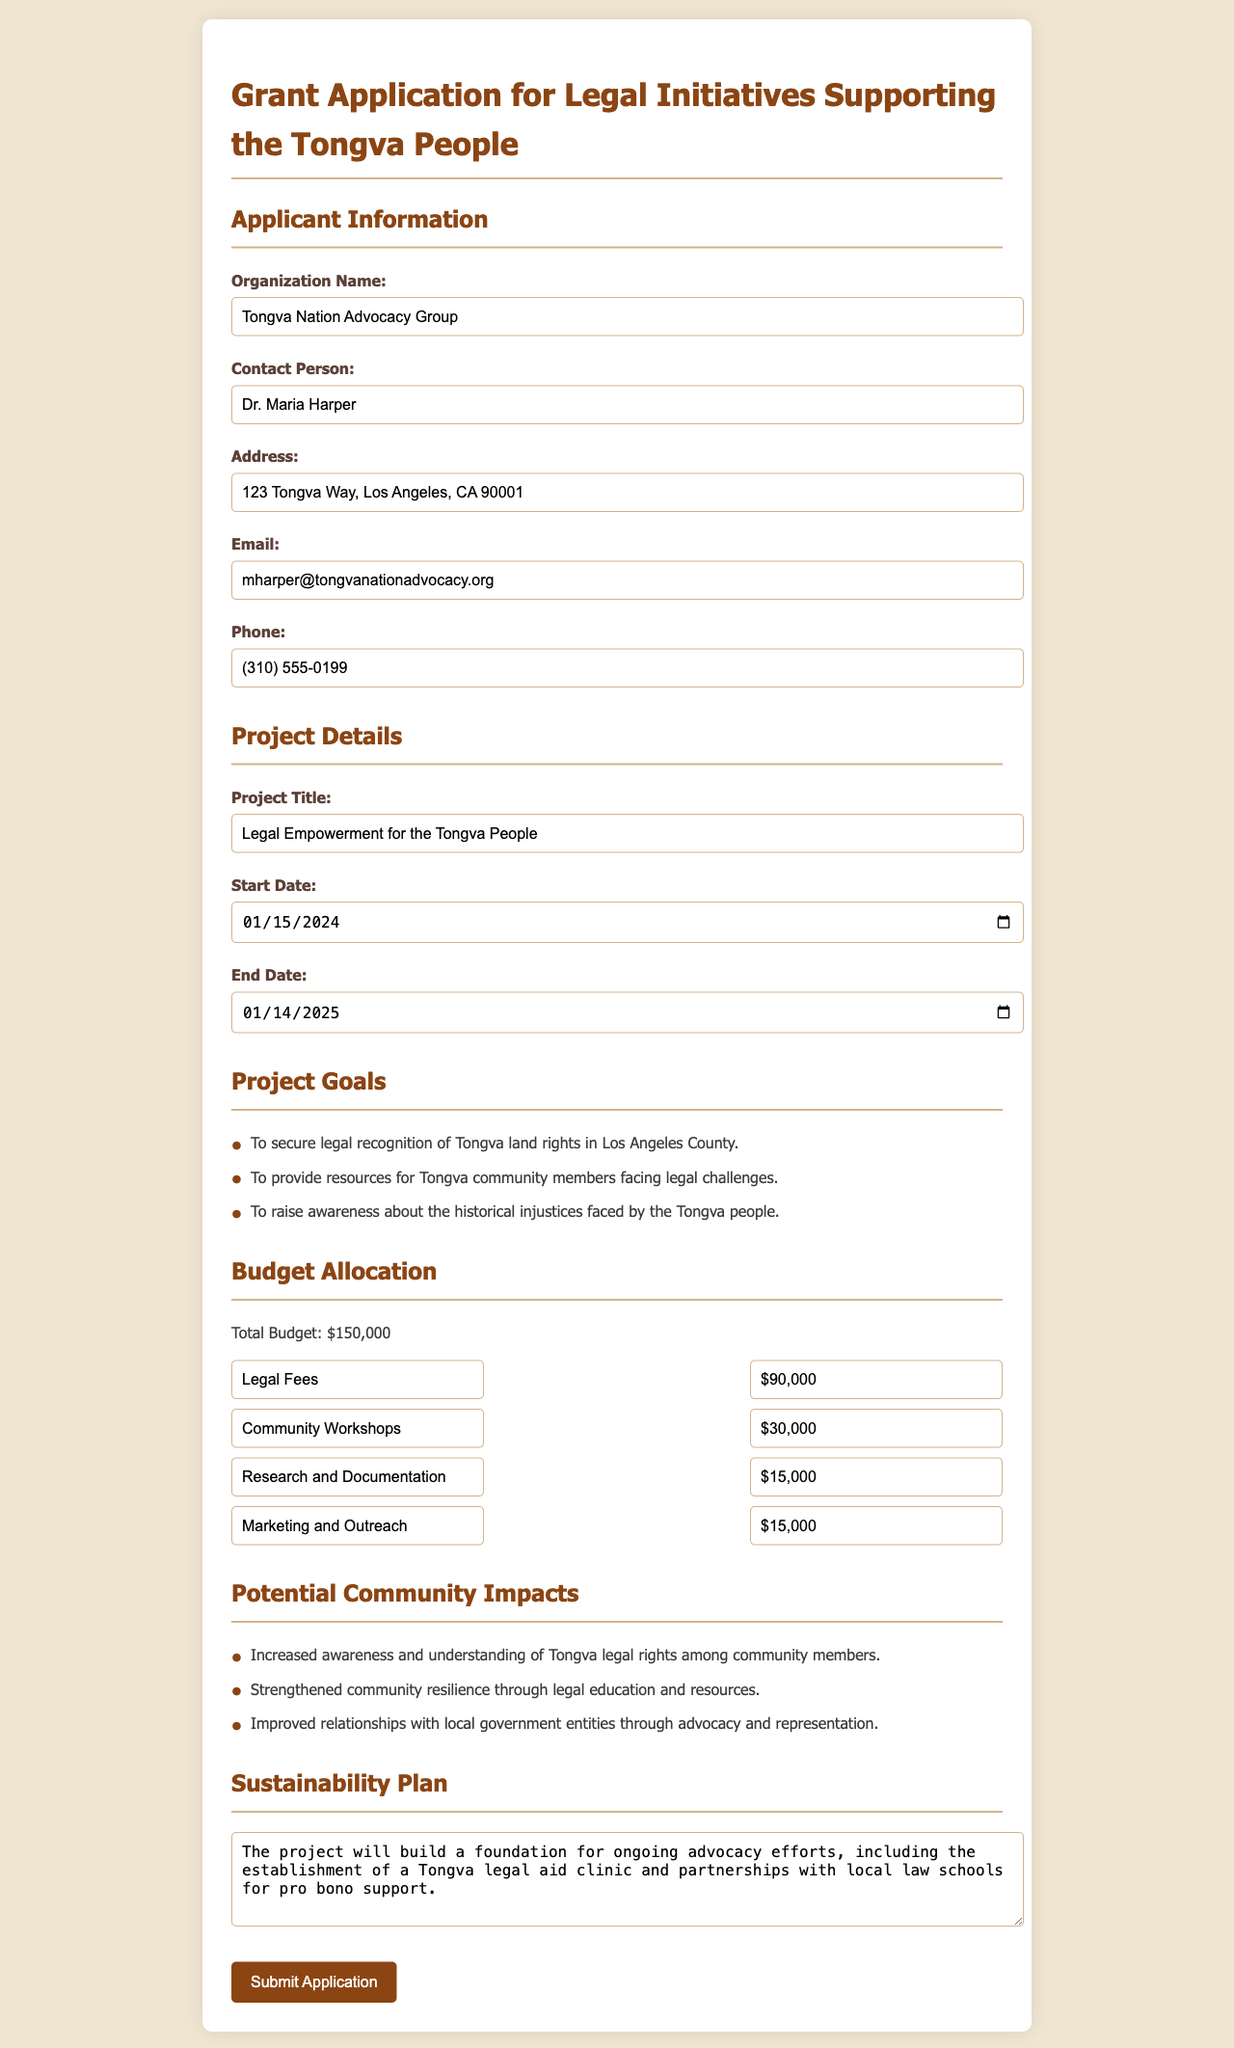What is the organization name? The organization name is mentioned in the applicant information section of the document.
Answer: Tongva Nation Advocacy Group Who is the contact person for the application? The contact person's name is provided in the applicant information section.
Answer: Dr. Maria Harper What is the project title? The project title is clearly stated in the project details section of the document.
Answer: Legal Empowerment for the Tongva People What is the total budget for the project? The total budget can be found in the budget allocation section.
Answer: $150,000 How much funding is allocated for legal fees? The amount for legal fees is specified in the budget allocation section.
Answer: $90,000 What are the start and end dates of the project? Both dates can be found in the project details section as they are provided clearly.
Answer: January 15, 2024 - January 14, 2025 Name one goal of the project. One of the goals is listed in the project goals section.
Answer: To secure legal recognition of Tongva land rights in Los Angeles County What is one potential community impact of the project? The impacts are listed in the potential community impacts section, and one can be chosen from those listed.
Answer: Increased awareness and understanding of Tongva legal rights among community members What is the sustainability plan focus? The sustainability plan is summarized in the sustainability plan section, highlighting future advocacy efforts.
Answer: Ongoing advocacy efforts, including a Tongva legal aid clinic 